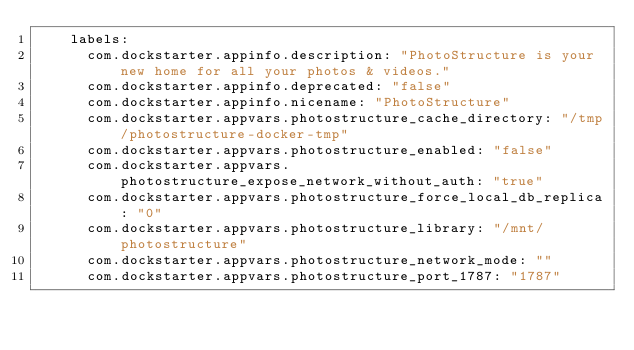<code> <loc_0><loc_0><loc_500><loc_500><_YAML_>    labels:
      com.dockstarter.appinfo.description: "PhotoStructure is your new home for all your photos & videos."
      com.dockstarter.appinfo.deprecated: "false"
      com.dockstarter.appinfo.nicename: "PhotoStructure"
      com.dockstarter.appvars.photostructure_cache_directory: "/tmp/photostructure-docker-tmp"
      com.dockstarter.appvars.photostructure_enabled: "false"
      com.dockstarter.appvars.photostructure_expose_network_without_auth: "true"
      com.dockstarter.appvars.photostructure_force_local_db_replica: "0"
      com.dockstarter.appvars.photostructure_library: "/mnt/photostructure"
      com.dockstarter.appvars.photostructure_network_mode: ""
      com.dockstarter.appvars.photostructure_port_1787: "1787"
</code> 